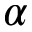<formula> <loc_0><loc_0><loc_500><loc_500>\alpha</formula> 